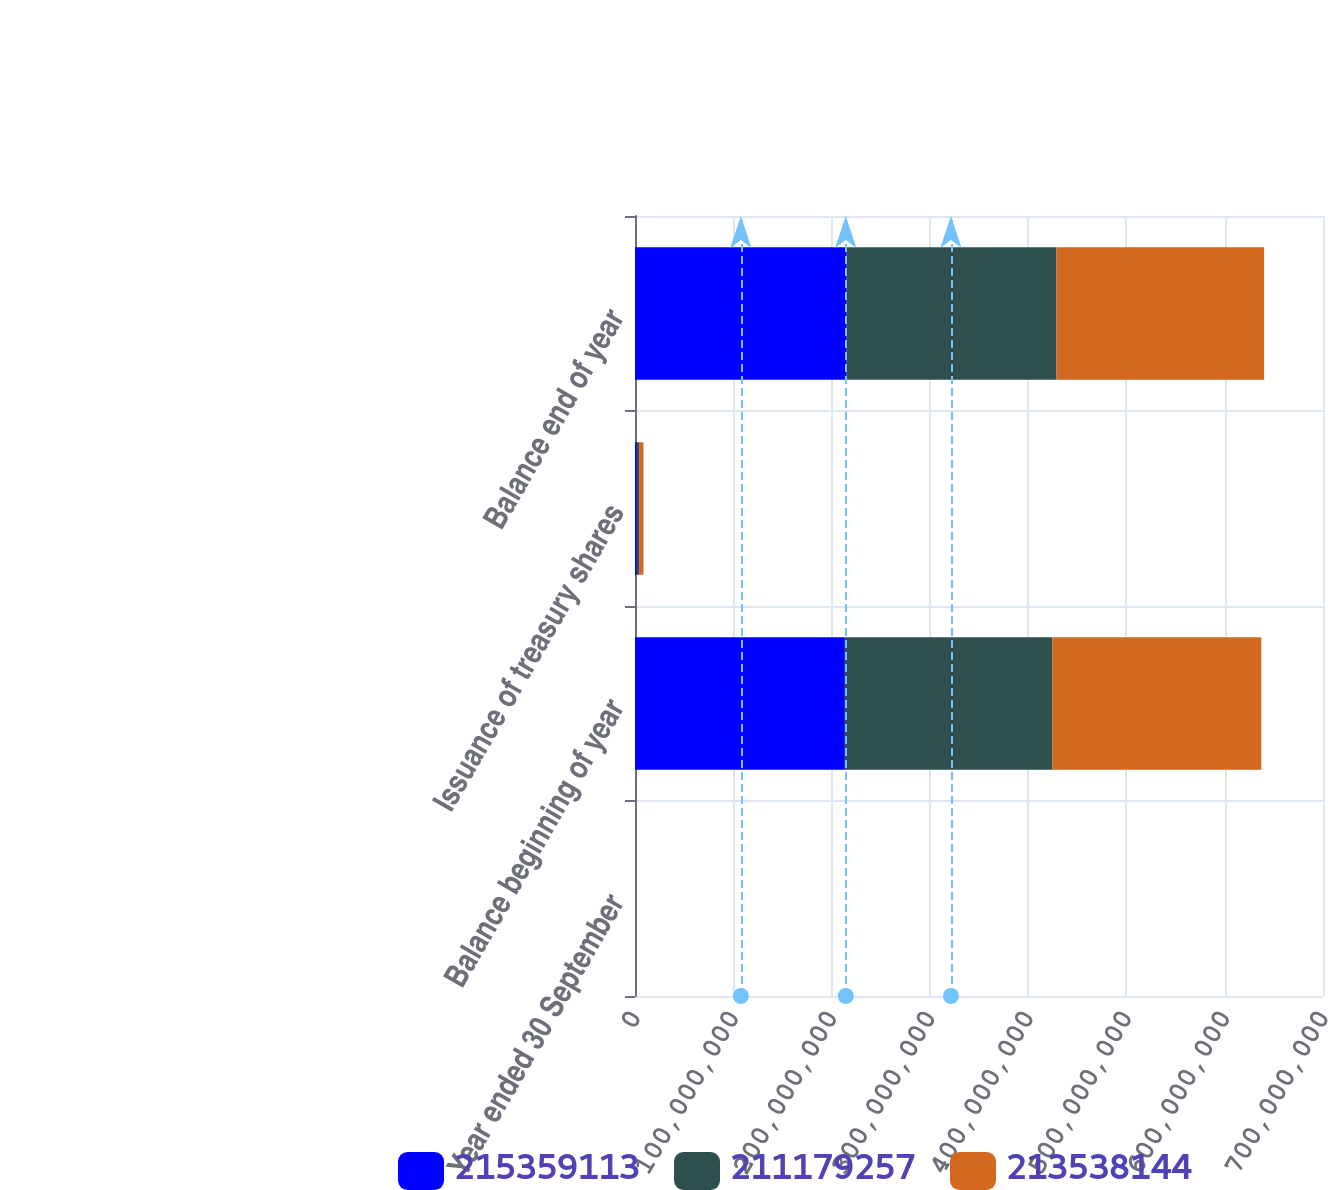<chart> <loc_0><loc_0><loc_500><loc_500><stacked_bar_chart><ecel><fcel>Year ended 30 September<fcel>Balance beginning of year<fcel>Issuance of treasury shares<fcel>Balance end of year<nl><fcel>2.15359e+08<fcel>2015<fcel>2.13538e+08<fcel>1.82097e+06<fcel>2.15359e+08<nl><fcel>2.11179e+08<fcel>2014<fcel>2.11179e+08<fcel>2.35889e+06<fcel>2.13538e+08<nl><fcel>2.13538e+08<fcel>2013<fcel>2.12476e+08<fcel>4.42439e+06<fcel>2.11179e+08<nl></chart> 